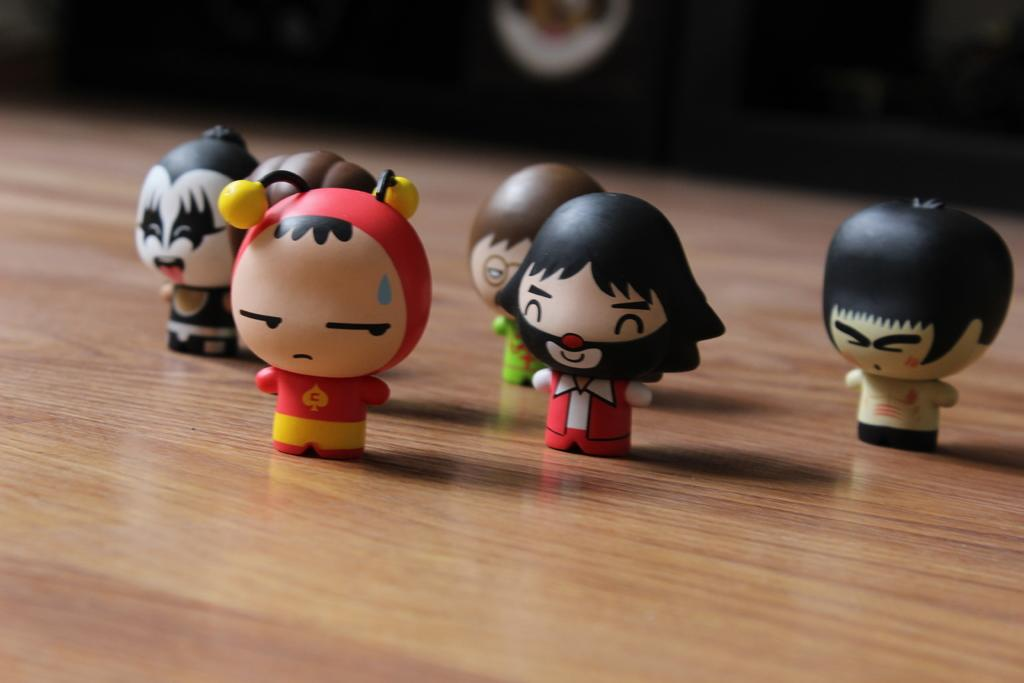What objects are on the table in the image? There are toys on a table in the image. Can you describe the object visible at the back of the image? Unfortunately, the provided facts do not give enough information to describe the object visible at the back of the image. How many clovers are on the table in the image? There are no clovers present on the table in the image. What type of vegetable is visible in the image? There is no vegetable visible in the image. 